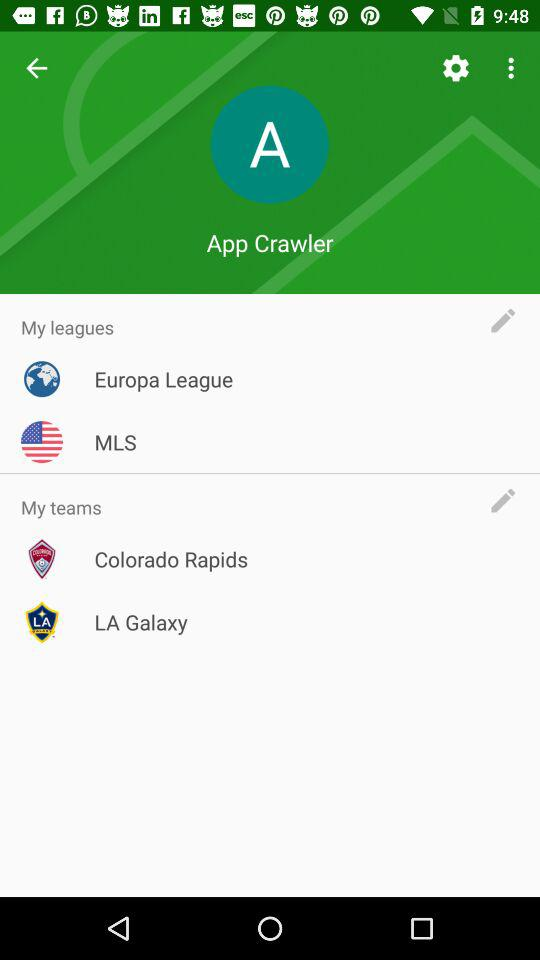What are the various leagues? The various leagues are "Europa League" and "MLS". 